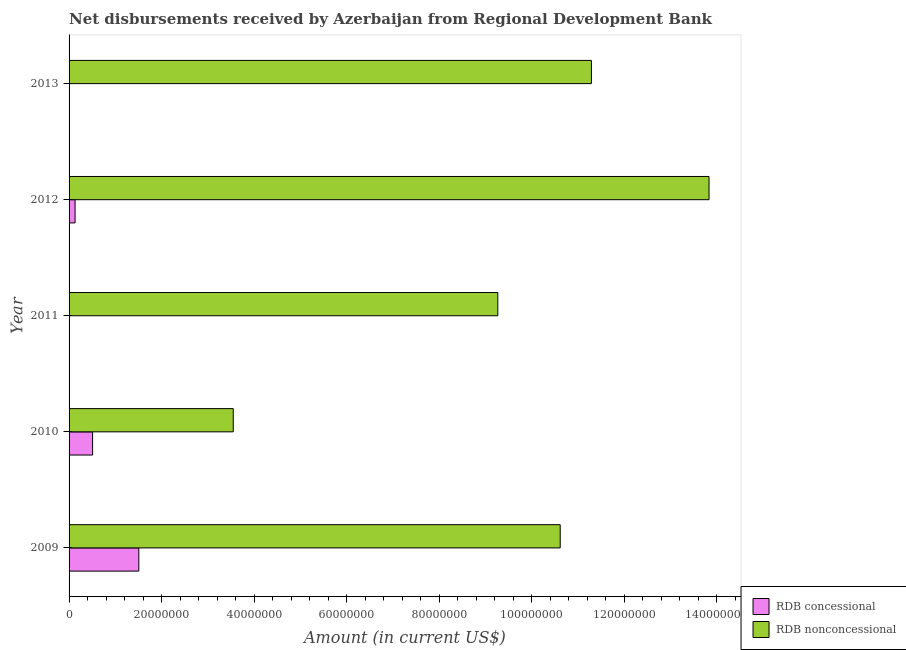How many different coloured bars are there?
Offer a very short reply. 2. Are the number of bars on each tick of the Y-axis equal?
Provide a succinct answer. No. How many bars are there on the 4th tick from the top?
Offer a very short reply. 2. How many bars are there on the 4th tick from the bottom?
Offer a very short reply. 2. What is the net concessional disbursements from rdb in 2011?
Keep it short and to the point. 0. Across all years, what is the maximum net non concessional disbursements from rdb?
Make the answer very short. 1.38e+08. Across all years, what is the minimum net non concessional disbursements from rdb?
Ensure brevity in your answer.  3.55e+07. What is the total net concessional disbursements from rdb in the graph?
Offer a very short reply. 2.15e+07. What is the difference between the net non concessional disbursements from rdb in 2009 and that in 2011?
Your response must be concise. 1.35e+07. What is the difference between the net concessional disbursements from rdb in 2012 and the net non concessional disbursements from rdb in 2010?
Provide a succinct answer. -3.42e+07. What is the average net non concessional disbursements from rdb per year?
Provide a succinct answer. 9.71e+07. In the year 2009, what is the difference between the net concessional disbursements from rdb and net non concessional disbursements from rdb?
Your answer should be very brief. -9.11e+07. What is the ratio of the net non concessional disbursements from rdb in 2010 to that in 2011?
Your answer should be compact. 0.38. What is the difference between the highest and the second highest net concessional disbursements from rdb?
Make the answer very short. 9.99e+06. What is the difference between the highest and the lowest net non concessional disbursements from rdb?
Offer a very short reply. 1.03e+08. In how many years, is the net non concessional disbursements from rdb greater than the average net non concessional disbursements from rdb taken over all years?
Your response must be concise. 3. How many years are there in the graph?
Your response must be concise. 5. What is the difference between two consecutive major ticks on the X-axis?
Make the answer very short. 2.00e+07. What is the title of the graph?
Ensure brevity in your answer.  Net disbursements received by Azerbaijan from Regional Development Bank. Does "Taxes on profits and capital gains" appear as one of the legend labels in the graph?
Give a very brief answer. No. What is the Amount (in current US$) in RDB concessional in 2009?
Your response must be concise. 1.51e+07. What is the Amount (in current US$) of RDB nonconcessional in 2009?
Ensure brevity in your answer.  1.06e+08. What is the Amount (in current US$) in RDB concessional in 2010?
Keep it short and to the point. 5.08e+06. What is the Amount (in current US$) of RDB nonconcessional in 2010?
Your answer should be very brief. 3.55e+07. What is the Amount (in current US$) of RDB concessional in 2011?
Provide a short and direct response. 0. What is the Amount (in current US$) in RDB nonconcessional in 2011?
Offer a very short reply. 9.27e+07. What is the Amount (in current US$) in RDB concessional in 2012?
Ensure brevity in your answer.  1.30e+06. What is the Amount (in current US$) of RDB nonconcessional in 2012?
Offer a terse response. 1.38e+08. What is the Amount (in current US$) in RDB nonconcessional in 2013?
Keep it short and to the point. 1.13e+08. Across all years, what is the maximum Amount (in current US$) of RDB concessional?
Give a very brief answer. 1.51e+07. Across all years, what is the maximum Amount (in current US$) of RDB nonconcessional?
Give a very brief answer. 1.38e+08. Across all years, what is the minimum Amount (in current US$) in RDB nonconcessional?
Offer a terse response. 3.55e+07. What is the total Amount (in current US$) in RDB concessional in the graph?
Provide a succinct answer. 2.15e+07. What is the total Amount (in current US$) of RDB nonconcessional in the graph?
Offer a terse response. 4.85e+08. What is the difference between the Amount (in current US$) of RDB concessional in 2009 and that in 2010?
Offer a very short reply. 9.99e+06. What is the difference between the Amount (in current US$) in RDB nonconcessional in 2009 and that in 2010?
Ensure brevity in your answer.  7.07e+07. What is the difference between the Amount (in current US$) in RDB nonconcessional in 2009 and that in 2011?
Make the answer very short. 1.35e+07. What is the difference between the Amount (in current US$) of RDB concessional in 2009 and that in 2012?
Ensure brevity in your answer.  1.38e+07. What is the difference between the Amount (in current US$) in RDB nonconcessional in 2009 and that in 2012?
Provide a short and direct response. -3.22e+07. What is the difference between the Amount (in current US$) in RDB nonconcessional in 2009 and that in 2013?
Your answer should be very brief. -6.74e+06. What is the difference between the Amount (in current US$) of RDB nonconcessional in 2010 and that in 2011?
Keep it short and to the point. -5.72e+07. What is the difference between the Amount (in current US$) of RDB concessional in 2010 and that in 2012?
Give a very brief answer. 3.79e+06. What is the difference between the Amount (in current US$) in RDB nonconcessional in 2010 and that in 2012?
Keep it short and to the point. -1.03e+08. What is the difference between the Amount (in current US$) in RDB nonconcessional in 2010 and that in 2013?
Ensure brevity in your answer.  -7.74e+07. What is the difference between the Amount (in current US$) in RDB nonconcessional in 2011 and that in 2012?
Offer a very short reply. -4.56e+07. What is the difference between the Amount (in current US$) in RDB nonconcessional in 2011 and that in 2013?
Keep it short and to the point. -2.02e+07. What is the difference between the Amount (in current US$) of RDB nonconcessional in 2012 and that in 2013?
Ensure brevity in your answer.  2.54e+07. What is the difference between the Amount (in current US$) in RDB concessional in 2009 and the Amount (in current US$) in RDB nonconcessional in 2010?
Provide a succinct answer. -2.04e+07. What is the difference between the Amount (in current US$) in RDB concessional in 2009 and the Amount (in current US$) in RDB nonconcessional in 2011?
Give a very brief answer. -7.76e+07. What is the difference between the Amount (in current US$) in RDB concessional in 2009 and the Amount (in current US$) in RDB nonconcessional in 2012?
Your answer should be very brief. -1.23e+08. What is the difference between the Amount (in current US$) in RDB concessional in 2009 and the Amount (in current US$) in RDB nonconcessional in 2013?
Provide a succinct answer. -9.78e+07. What is the difference between the Amount (in current US$) in RDB concessional in 2010 and the Amount (in current US$) in RDB nonconcessional in 2011?
Keep it short and to the point. -8.76e+07. What is the difference between the Amount (in current US$) of RDB concessional in 2010 and the Amount (in current US$) of RDB nonconcessional in 2012?
Your answer should be very brief. -1.33e+08. What is the difference between the Amount (in current US$) of RDB concessional in 2010 and the Amount (in current US$) of RDB nonconcessional in 2013?
Keep it short and to the point. -1.08e+08. What is the difference between the Amount (in current US$) of RDB concessional in 2012 and the Amount (in current US$) of RDB nonconcessional in 2013?
Offer a very short reply. -1.12e+08. What is the average Amount (in current US$) in RDB concessional per year?
Your response must be concise. 4.29e+06. What is the average Amount (in current US$) of RDB nonconcessional per year?
Make the answer very short. 9.71e+07. In the year 2009, what is the difference between the Amount (in current US$) of RDB concessional and Amount (in current US$) of RDB nonconcessional?
Give a very brief answer. -9.11e+07. In the year 2010, what is the difference between the Amount (in current US$) in RDB concessional and Amount (in current US$) in RDB nonconcessional?
Provide a succinct answer. -3.04e+07. In the year 2012, what is the difference between the Amount (in current US$) of RDB concessional and Amount (in current US$) of RDB nonconcessional?
Provide a short and direct response. -1.37e+08. What is the ratio of the Amount (in current US$) of RDB concessional in 2009 to that in 2010?
Give a very brief answer. 2.96. What is the ratio of the Amount (in current US$) in RDB nonconcessional in 2009 to that in 2010?
Offer a terse response. 2.99. What is the ratio of the Amount (in current US$) of RDB nonconcessional in 2009 to that in 2011?
Ensure brevity in your answer.  1.15. What is the ratio of the Amount (in current US$) of RDB concessional in 2009 to that in 2012?
Your answer should be very brief. 11.62. What is the ratio of the Amount (in current US$) of RDB nonconcessional in 2009 to that in 2012?
Keep it short and to the point. 0.77. What is the ratio of the Amount (in current US$) of RDB nonconcessional in 2009 to that in 2013?
Your response must be concise. 0.94. What is the ratio of the Amount (in current US$) of RDB nonconcessional in 2010 to that in 2011?
Provide a short and direct response. 0.38. What is the ratio of the Amount (in current US$) of RDB concessional in 2010 to that in 2012?
Ensure brevity in your answer.  3.92. What is the ratio of the Amount (in current US$) of RDB nonconcessional in 2010 to that in 2012?
Your answer should be very brief. 0.26. What is the ratio of the Amount (in current US$) of RDB nonconcessional in 2010 to that in 2013?
Give a very brief answer. 0.31. What is the ratio of the Amount (in current US$) of RDB nonconcessional in 2011 to that in 2012?
Your answer should be compact. 0.67. What is the ratio of the Amount (in current US$) in RDB nonconcessional in 2011 to that in 2013?
Ensure brevity in your answer.  0.82. What is the ratio of the Amount (in current US$) in RDB nonconcessional in 2012 to that in 2013?
Provide a short and direct response. 1.23. What is the difference between the highest and the second highest Amount (in current US$) in RDB concessional?
Provide a succinct answer. 9.99e+06. What is the difference between the highest and the second highest Amount (in current US$) in RDB nonconcessional?
Your response must be concise. 2.54e+07. What is the difference between the highest and the lowest Amount (in current US$) of RDB concessional?
Offer a very short reply. 1.51e+07. What is the difference between the highest and the lowest Amount (in current US$) in RDB nonconcessional?
Provide a succinct answer. 1.03e+08. 